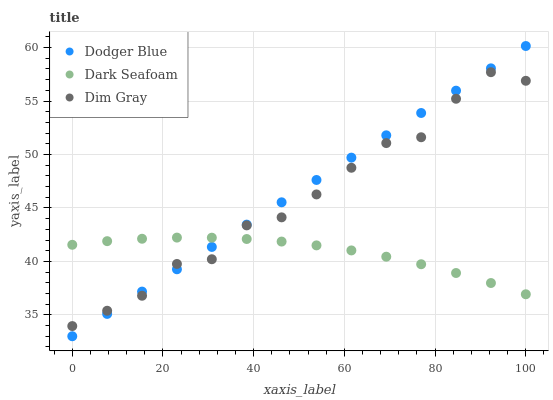Does Dark Seafoam have the minimum area under the curve?
Answer yes or no. Yes. Does Dodger Blue have the maximum area under the curve?
Answer yes or no. Yes. Does Dim Gray have the minimum area under the curve?
Answer yes or no. No. Does Dim Gray have the maximum area under the curve?
Answer yes or no. No. Is Dodger Blue the smoothest?
Answer yes or no. Yes. Is Dim Gray the roughest?
Answer yes or no. Yes. Is Dim Gray the smoothest?
Answer yes or no. No. Is Dodger Blue the roughest?
Answer yes or no. No. Does Dodger Blue have the lowest value?
Answer yes or no. Yes. Does Dim Gray have the lowest value?
Answer yes or no. No. Does Dodger Blue have the highest value?
Answer yes or no. Yes. Does Dim Gray have the highest value?
Answer yes or no. No. Does Dark Seafoam intersect Dim Gray?
Answer yes or no. Yes. Is Dark Seafoam less than Dim Gray?
Answer yes or no. No. Is Dark Seafoam greater than Dim Gray?
Answer yes or no. No. 